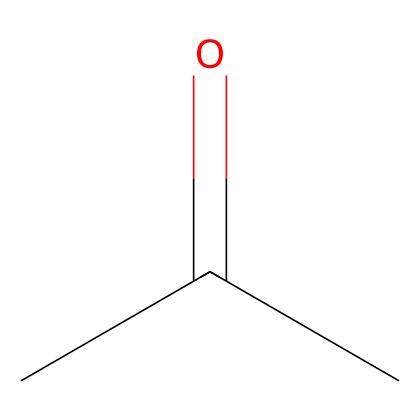What is the name of this chemical? The SMILES representation "CC(=O)C" corresponds to a chemical with the structure which features a carbonyl group (C=O) with two other carbons attached, making it acetone, a common solvent.
Answer: acetone How many carbon atoms are in this chemical? In the SMILES "CC(=O)C", there are three total carbon atoms: two in the linear part and one in the carbonyl group.
Answer: three What type of functional group does this chemical contain? The presence of the carbonyl group (C=O) in the structure indicates that this chemical is a ketone, specifically because it has the carbonyl group flanked by two carbon atoms.
Answer: ketone How many hydrogen atoms are bonded to the central carbon atom? The central carbon atom in the structure is connected to one carbon (C), one oxygen (O) and has two hydrogen atoms bonded to it, making it a total of two hydrogen atoms.
Answer: two What is the characteristic odor associated with this compound? Acetone is known for having a sweet, fruity smell, which is characteristic of many ketones, making it easy to identify.
Answer: sweet What is this chemical typically used for? Acetone is commonly used as a solvent in industries and in laboratories for cleaning and thinning materials due to its effectiveness in dissolving various substances.
Answer: solvent What is the boiling point range of this chemical? Acetone has a boiling point of around 56 degrees Celsius, making it a volatile liquid that evaporates easily at room temperature.
Answer: 56 degrees Celsius 